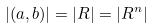Convert formula to latex. <formula><loc_0><loc_0><loc_500><loc_500>| ( a , b ) | = | R | = | R ^ { n } |</formula> 